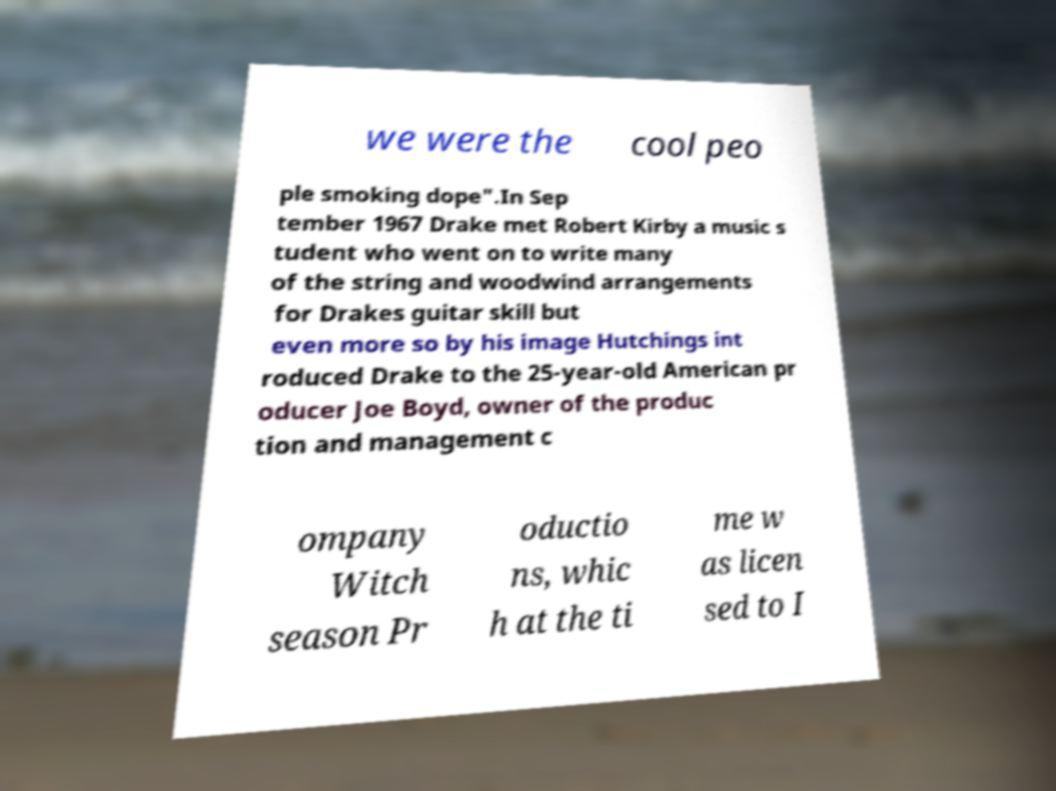Could you assist in decoding the text presented in this image and type it out clearly? we were the cool peo ple smoking dope".In Sep tember 1967 Drake met Robert Kirby a music s tudent who went on to write many of the string and woodwind arrangements for Drakes guitar skill but even more so by his image Hutchings int roduced Drake to the 25-year-old American pr oducer Joe Boyd, owner of the produc tion and management c ompany Witch season Pr oductio ns, whic h at the ti me w as licen sed to I 